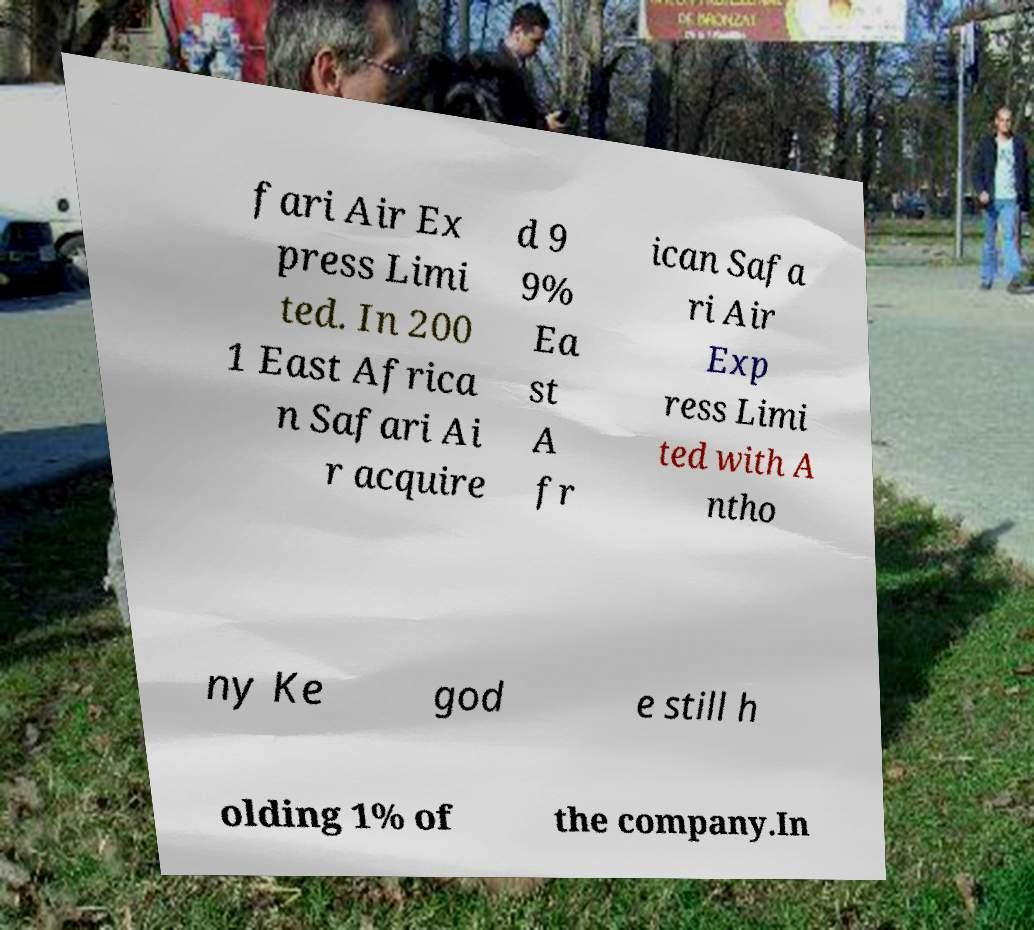Can you read and provide the text displayed in the image?This photo seems to have some interesting text. Can you extract and type it out for me? fari Air Ex press Limi ted. In 200 1 East Africa n Safari Ai r acquire d 9 9% Ea st A fr ican Safa ri Air Exp ress Limi ted with A ntho ny Ke god e still h olding 1% of the company.In 